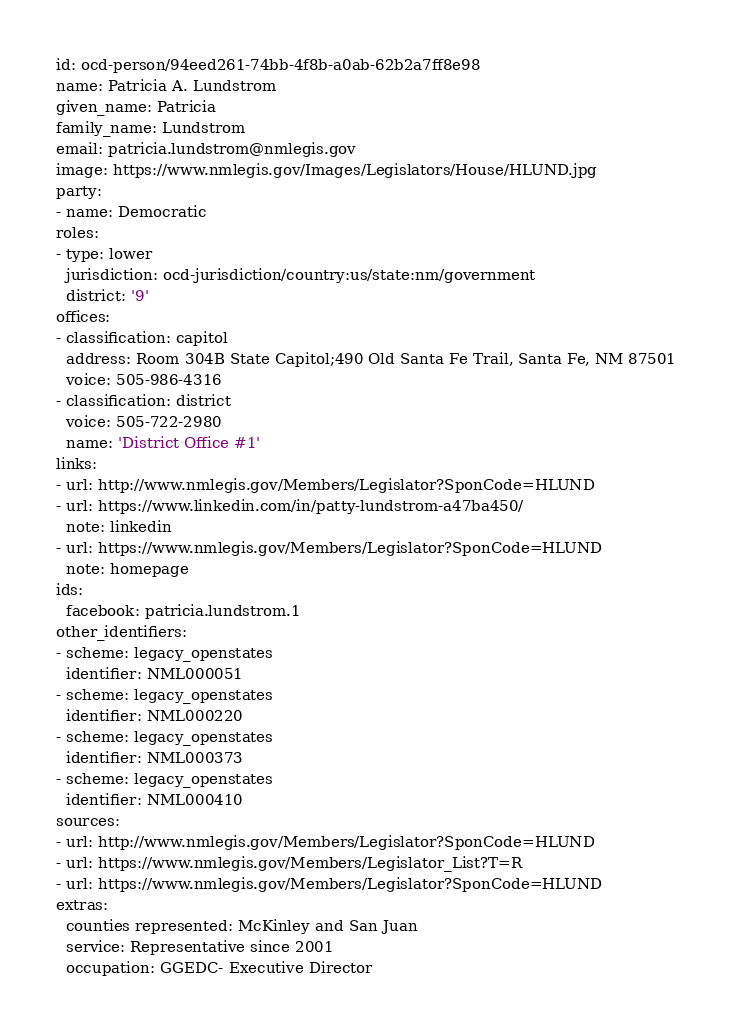Convert code to text. <code><loc_0><loc_0><loc_500><loc_500><_YAML_>id: ocd-person/94eed261-74bb-4f8b-a0ab-62b2a7ff8e98
name: Patricia A. Lundstrom
given_name: Patricia
family_name: Lundstrom
email: patricia.lundstrom@nmlegis.gov
image: https://www.nmlegis.gov/Images/Legislators/House/HLUND.jpg
party:
- name: Democratic
roles:
- type: lower
  jurisdiction: ocd-jurisdiction/country:us/state:nm/government
  district: '9'
offices:
- classification: capitol
  address: Room 304B State Capitol;490 Old Santa Fe Trail, Santa Fe, NM 87501
  voice: 505-986-4316
- classification: district
  voice: 505-722-2980
  name: 'District Office #1'
links:
- url: http://www.nmlegis.gov/Members/Legislator?SponCode=HLUND
- url: https://www.linkedin.com/in/patty-lundstrom-a47ba450/
  note: linkedin
- url: https://www.nmlegis.gov/Members/Legislator?SponCode=HLUND
  note: homepage
ids:
  facebook: patricia.lundstrom.1
other_identifiers:
- scheme: legacy_openstates
  identifier: NML000051
- scheme: legacy_openstates
  identifier: NML000220
- scheme: legacy_openstates
  identifier: NML000373
- scheme: legacy_openstates
  identifier: NML000410
sources:
- url: http://www.nmlegis.gov/Members/Legislator?SponCode=HLUND
- url: https://www.nmlegis.gov/Members/Legislator_List?T=R
- url: https://www.nmlegis.gov/Members/Legislator?SponCode=HLUND
extras:
  counties represented: McKinley and San Juan
  service: Representative since 2001
  occupation: GGEDC- Executive Director
</code> 